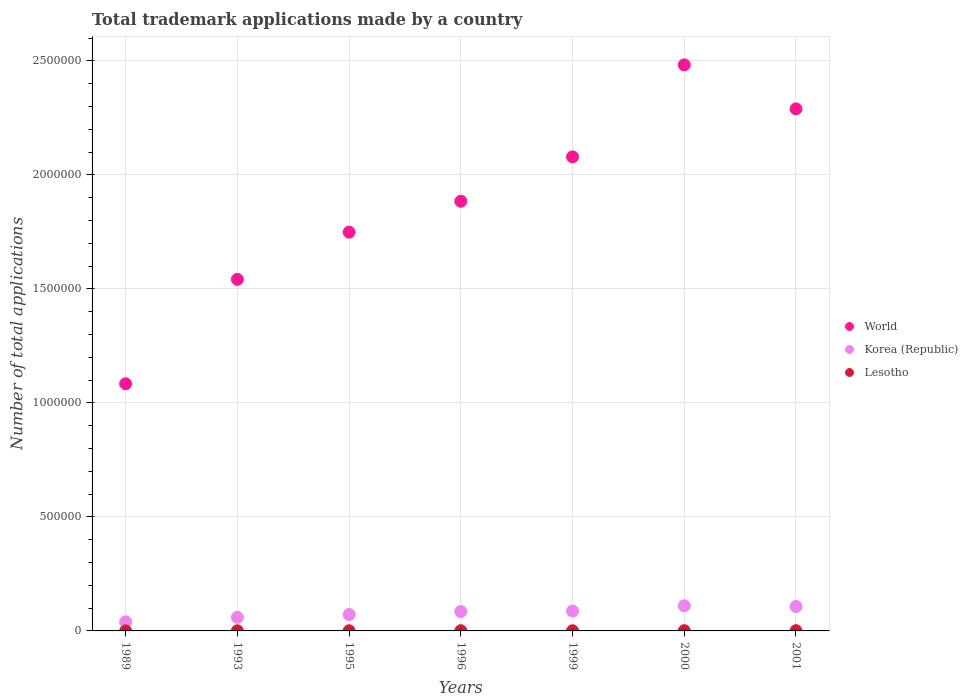How many different coloured dotlines are there?
Provide a short and direct response. 3. Is the number of dotlines equal to the number of legend labels?
Offer a very short reply. Yes. What is the number of applications made by in Korea (Republic) in 1995?
Make the answer very short. 7.19e+04. Across all years, what is the maximum number of applications made by in Lesotho?
Keep it short and to the point. 1083. Across all years, what is the minimum number of applications made by in Lesotho?
Give a very brief answer. 98. In which year was the number of applications made by in Korea (Republic) maximum?
Your answer should be very brief. 2000. In which year was the number of applications made by in Lesotho minimum?
Offer a very short reply. 1989. What is the total number of applications made by in Lesotho in the graph?
Provide a short and direct response. 5022. What is the difference between the number of applications made by in Lesotho in 1993 and that in 1999?
Provide a succinct answer. -84. What is the difference between the number of applications made by in World in 1989 and the number of applications made by in Korea (Republic) in 1999?
Your answer should be very brief. 9.97e+05. What is the average number of applications made by in Lesotho per year?
Give a very brief answer. 717.43. In the year 1996, what is the difference between the number of applications made by in World and number of applications made by in Korea (Republic)?
Keep it short and to the point. 1.80e+06. In how many years, is the number of applications made by in Lesotho greater than 1600000?
Keep it short and to the point. 0. What is the ratio of the number of applications made by in Korea (Republic) in 1996 to that in 1999?
Your answer should be compact. 0.97. What is the difference between the highest and the second highest number of applications made by in World?
Offer a terse response. 1.93e+05. What is the difference between the highest and the lowest number of applications made by in Lesotho?
Keep it short and to the point. 985. Is it the case that in every year, the sum of the number of applications made by in World and number of applications made by in Lesotho  is greater than the number of applications made by in Korea (Republic)?
Your answer should be compact. Yes. Does the number of applications made by in Lesotho monotonically increase over the years?
Offer a very short reply. No. Is the number of applications made by in World strictly greater than the number of applications made by in Lesotho over the years?
Offer a very short reply. Yes. How many dotlines are there?
Offer a very short reply. 3. Does the graph contain grids?
Provide a succinct answer. Yes. Where does the legend appear in the graph?
Your response must be concise. Center right. How are the legend labels stacked?
Ensure brevity in your answer.  Vertical. What is the title of the graph?
Offer a very short reply. Total trademark applications made by a country. What is the label or title of the X-axis?
Give a very brief answer. Years. What is the label or title of the Y-axis?
Give a very brief answer. Number of total applications. What is the Number of total applications of World in 1989?
Provide a short and direct response. 1.08e+06. What is the Number of total applications of Korea (Republic) in 1989?
Keep it short and to the point. 3.98e+04. What is the Number of total applications of Lesotho in 1989?
Ensure brevity in your answer.  98. What is the Number of total applications in World in 1993?
Make the answer very short. 1.54e+06. What is the Number of total applications in Korea (Republic) in 1993?
Provide a succinct answer. 5.96e+04. What is the Number of total applications of Lesotho in 1993?
Offer a terse response. 581. What is the Number of total applications of World in 1995?
Your answer should be very brief. 1.75e+06. What is the Number of total applications of Korea (Republic) in 1995?
Give a very brief answer. 7.19e+04. What is the Number of total applications of Lesotho in 1995?
Your answer should be compact. 668. What is the Number of total applications in World in 1996?
Provide a short and direct response. 1.88e+06. What is the Number of total applications in Korea (Republic) in 1996?
Provide a short and direct response. 8.51e+04. What is the Number of total applications in Lesotho in 1996?
Offer a terse response. 918. What is the Number of total applications of World in 1999?
Ensure brevity in your answer.  2.08e+06. What is the Number of total applications in Korea (Republic) in 1999?
Ensure brevity in your answer.  8.73e+04. What is the Number of total applications in Lesotho in 1999?
Provide a short and direct response. 665. What is the Number of total applications in World in 2000?
Your response must be concise. 2.48e+06. What is the Number of total applications in Korea (Republic) in 2000?
Provide a succinct answer. 1.10e+05. What is the Number of total applications in Lesotho in 2000?
Your answer should be compact. 1083. What is the Number of total applications of World in 2001?
Your response must be concise. 2.29e+06. What is the Number of total applications in Korea (Republic) in 2001?
Keep it short and to the point. 1.07e+05. What is the Number of total applications of Lesotho in 2001?
Your response must be concise. 1009. Across all years, what is the maximum Number of total applications of World?
Your answer should be compact. 2.48e+06. Across all years, what is the maximum Number of total applications in Korea (Republic)?
Your answer should be very brief. 1.10e+05. Across all years, what is the maximum Number of total applications in Lesotho?
Give a very brief answer. 1083. Across all years, what is the minimum Number of total applications of World?
Your response must be concise. 1.08e+06. Across all years, what is the minimum Number of total applications in Korea (Republic)?
Provide a short and direct response. 3.98e+04. What is the total Number of total applications of World in the graph?
Provide a succinct answer. 1.31e+07. What is the total Number of total applications in Korea (Republic) in the graph?
Your response must be concise. 5.61e+05. What is the total Number of total applications in Lesotho in the graph?
Ensure brevity in your answer.  5022. What is the difference between the Number of total applications in World in 1989 and that in 1993?
Ensure brevity in your answer.  -4.58e+05. What is the difference between the Number of total applications of Korea (Republic) in 1989 and that in 1993?
Keep it short and to the point. -1.98e+04. What is the difference between the Number of total applications of Lesotho in 1989 and that in 1993?
Make the answer very short. -483. What is the difference between the Number of total applications in World in 1989 and that in 1995?
Give a very brief answer. -6.65e+05. What is the difference between the Number of total applications in Korea (Republic) in 1989 and that in 1995?
Make the answer very short. -3.20e+04. What is the difference between the Number of total applications of Lesotho in 1989 and that in 1995?
Ensure brevity in your answer.  -570. What is the difference between the Number of total applications in World in 1989 and that in 1996?
Your answer should be very brief. -8.00e+05. What is the difference between the Number of total applications of Korea (Republic) in 1989 and that in 1996?
Provide a short and direct response. -4.52e+04. What is the difference between the Number of total applications in Lesotho in 1989 and that in 1996?
Provide a succinct answer. -820. What is the difference between the Number of total applications in World in 1989 and that in 1999?
Provide a succinct answer. -9.95e+05. What is the difference between the Number of total applications of Korea (Republic) in 1989 and that in 1999?
Keep it short and to the point. -4.75e+04. What is the difference between the Number of total applications of Lesotho in 1989 and that in 1999?
Your response must be concise. -567. What is the difference between the Number of total applications in World in 1989 and that in 2000?
Offer a terse response. -1.40e+06. What is the difference between the Number of total applications of Korea (Republic) in 1989 and that in 2000?
Give a very brief answer. -7.02e+04. What is the difference between the Number of total applications of Lesotho in 1989 and that in 2000?
Your answer should be very brief. -985. What is the difference between the Number of total applications of World in 1989 and that in 2001?
Your answer should be compact. -1.21e+06. What is the difference between the Number of total applications of Korea (Republic) in 1989 and that in 2001?
Make the answer very short. -6.73e+04. What is the difference between the Number of total applications in Lesotho in 1989 and that in 2001?
Provide a short and direct response. -911. What is the difference between the Number of total applications of World in 1993 and that in 1995?
Your response must be concise. -2.07e+05. What is the difference between the Number of total applications in Korea (Republic) in 1993 and that in 1995?
Offer a terse response. -1.23e+04. What is the difference between the Number of total applications of Lesotho in 1993 and that in 1995?
Provide a short and direct response. -87. What is the difference between the Number of total applications of World in 1993 and that in 1996?
Offer a terse response. -3.42e+05. What is the difference between the Number of total applications of Korea (Republic) in 1993 and that in 1996?
Your response must be concise. -2.55e+04. What is the difference between the Number of total applications of Lesotho in 1993 and that in 1996?
Your answer should be very brief. -337. What is the difference between the Number of total applications of World in 1993 and that in 1999?
Offer a very short reply. -5.37e+05. What is the difference between the Number of total applications in Korea (Republic) in 1993 and that in 1999?
Ensure brevity in your answer.  -2.77e+04. What is the difference between the Number of total applications in Lesotho in 1993 and that in 1999?
Give a very brief answer. -84. What is the difference between the Number of total applications of World in 1993 and that in 2000?
Make the answer very short. -9.41e+05. What is the difference between the Number of total applications of Korea (Republic) in 1993 and that in 2000?
Your answer should be compact. -5.05e+04. What is the difference between the Number of total applications of Lesotho in 1993 and that in 2000?
Offer a very short reply. -502. What is the difference between the Number of total applications of World in 1993 and that in 2001?
Keep it short and to the point. -7.48e+05. What is the difference between the Number of total applications of Korea (Republic) in 1993 and that in 2001?
Ensure brevity in your answer.  -4.75e+04. What is the difference between the Number of total applications of Lesotho in 1993 and that in 2001?
Give a very brief answer. -428. What is the difference between the Number of total applications in World in 1995 and that in 1996?
Offer a terse response. -1.35e+05. What is the difference between the Number of total applications of Korea (Republic) in 1995 and that in 1996?
Your answer should be compact. -1.32e+04. What is the difference between the Number of total applications in Lesotho in 1995 and that in 1996?
Make the answer very short. -250. What is the difference between the Number of total applications of World in 1995 and that in 1999?
Offer a very short reply. -3.30e+05. What is the difference between the Number of total applications of Korea (Republic) in 1995 and that in 1999?
Your answer should be compact. -1.55e+04. What is the difference between the Number of total applications in Lesotho in 1995 and that in 1999?
Make the answer very short. 3. What is the difference between the Number of total applications in World in 1995 and that in 2000?
Provide a succinct answer. -7.34e+05. What is the difference between the Number of total applications of Korea (Republic) in 1995 and that in 2000?
Give a very brief answer. -3.82e+04. What is the difference between the Number of total applications in Lesotho in 1995 and that in 2000?
Keep it short and to the point. -415. What is the difference between the Number of total applications in World in 1995 and that in 2001?
Offer a very short reply. -5.41e+05. What is the difference between the Number of total applications in Korea (Republic) in 1995 and that in 2001?
Ensure brevity in your answer.  -3.53e+04. What is the difference between the Number of total applications of Lesotho in 1995 and that in 2001?
Your answer should be very brief. -341. What is the difference between the Number of total applications in World in 1996 and that in 1999?
Your answer should be compact. -1.95e+05. What is the difference between the Number of total applications of Korea (Republic) in 1996 and that in 1999?
Your answer should be very brief. -2270. What is the difference between the Number of total applications of Lesotho in 1996 and that in 1999?
Your response must be concise. 253. What is the difference between the Number of total applications of World in 1996 and that in 2000?
Provide a short and direct response. -5.98e+05. What is the difference between the Number of total applications of Korea (Republic) in 1996 and that in 2000?
Offer a very short reply. -2.50e+04. What is the difference between the Number of total applications in Lesotho in 1996 and that in 2000?
Keep it short and to the point. -165. What is the difference between the Number of total applications of World in 1996 and that in 2001?
Give a very brief answer. -4.05e+05. What is the difference between the Number of total applications in Korea (Republic) in 1996 and that in 2001?
Your answer should be compact. -2.21e+04. What is the difference between the Number of total applications of Lesotho in 1996 and that in 2001?
Your answer should be very brief. -91. What is the difference between the Number of total applications in World in 1999 and that in 2000?
Ensure brevity in your answer.  -4.03e+05. What is the difference between the Number of total applications in Korea (Republic) in 1999 and that in 2000?
Keep it short and to the point. -2.27e+04. What is the difference between the Number of total applications of Lesotho in 1999 and that in 2000?
Your answer should be compact. -418. What is the difference between the Number of total applications of World in 1999 and that in 2001?
Offer a terse response. -2.11e+05. What is the difference between the Number of total applications in Korea (Republic) in 1999 and that in 2001?
Give a very brief answer. -1.98e+04. What is the difference between the Number of total applications of Lesotho in 1999 and that in 2001?
Offer a terse response. -344. What is the difference between the Number of total applications of World in 2000 and that in 2001?
Your answer should be compact. 1.93e+05. What is the difference between the Number of total applications in Korea (Republic) in 2000 and that in 2001?
Make the answer very short. 2936. What is the difference between the Number of total applications of World in 1989 and the Number of total applications of Korea (Republic) in 1993?
Your answer should be very brief. 1.02e+06. What is the difference between the Number of total applications in World in 1989 and the Number of total applications in Lesotho in 1993?
Provide a short and direct response. 1.08e+06. What is the difference between the Number of total applications of Korea (Republic) in 1989 and the Number of total applications of Lesotho in 1993?
Offer a terse response. 3.93e+04. What is the difference between the Number of total applications in World in 1989 and the Number of total applications in Korea (Republic) in 1995?
Your answer should be compact. 1.01e+06. What is the difference between the Number of total applications of World in 1989 and the Number of total applications of Lesotho in 1995?
Your answer should be very brief. 1.08e+06. What is the difference between the Number of total applications in Korea (Republic) in 1989 and the Number of total applications in Lesotho in 1995?
Offer a terse response. 3.92e+04. What is the difference between the Number of total applications of World in 1989 and the Number of total applications of Korea (Republic) in 1996?
Your response must be concise. 9.99e+05. What is the difference between the Number of total applications of World in 1989 and the Number of total applications of Lesotho in 1996?
Your answer should be very brief. 1.08e+06. What is the difference between the Number of total applications in Korea (Republic) in 1989 and the Number of total applications in Lesotho in 1996?
Keep it short and to the point. 3.89e+04. What is the difference between the Number of total applications in World in 1989 and the Number of total applications in Korea (Republic) in 1999?
Offer a very short reply. 9.97e+05. What is the difference between the Number of total applications in World in 1989 and the Number of total applications in Lesotho in 1999?
Make the answer very short. 1.08e+06. What is the difference between the Number of total applications in Korea (Republic) in 1989 and the Number of total applications in Lesotho in 1999?
Provide a succinct answer. 3.92e+04. What is the difference between the Number of total applications of World in 1989 and the Number of total applications of Korea (Republic) in 2000?
Give a very brief answer. 9.74e+05. What is the difference between the Number of total applications in World in 1989 and the Number of total applications in Lesotho in 2000?
Keep it short and to the point. 1.08e+06. What is the difference between the Number of total applications of Korea (Republic) in 1989 and the Number of total applications of Lesotho in 2000?
Offer a very short reply. 3.87e+04. What is the difference between the Number of total applications in World in 1989 and the Number of total applications in Korea (Republic) in 2001?
Offer a very short reply. 9.77e+05. What is the difference between the Number of total applications in World in 1989 and the Number of total applications in Lesotho in 2001?
Ensure brevity in your answer.  1.08e+06. What is the difference between the Number of total applications in Korea (Republic) in 1989 and the Number of total applications in Lesotho in 2001?
Your answer should be compact. 3.88e+04. What is the difference between the Number of total applications in World in 1993 and the Number of total applications in Korea (Republic) in 1995?
Your response must be concise. 1.47e+06. What is the difference between the Number of total applications of World in 1993 and the Number of total applications of Lesotho in 1995?
Offer a very short reply. 1.54e+06. What is the difference between the Number of total applications in Korea (Republic) in 1993 and the Number of total applications in Lesotho in 1995?
Make the answer very short. 5.89e+04. What is the difference between the Number of total applications of World in 1993 and the Number of total applications of Korea (Republic) in 1996?
Your answer should be compact. 1.46e+06. What is the difference between the Number of total applications in World in 1993 and the Number of total applications in Lesotho in 1996?
Give a very brief answer. 1.54e+06. What is the difference between the Number of total applications of Korea (Republic) in 1993 and the Number of total applications of Lesotho in 1996?
Provide a succinct answer. 5.87e+04. What is the difference between the Number of total applications in World in 1993 and the Number of total applications in Korea (Republic) in 1999?
Your answer should be compact. 1.45e+06. What is the difference between the Number of total applications of World in 1993 and the Number of total applications of Lesotho in 1999?
Provide a succinct answer. 1.54e+06. What is the difference between the Number of total applications in Korea (Republic) in 1993 and the Number of total applications in Lesotho in 1999?
Offer a very short reply. 5.89e+04. What is the difference between the Number of total applications of World in 1993 and the Number of total applications of Korea (Republic) in 2000?
Offer a terse response. 1.43e+06. What is the difference between the Number of total applications in World in 1993 and the Number of total applications in Lesotho in 2000?
Offer a terse response. 1.54e+06. What is the difference between the Number of total applications in Korea (Republic) in 1993 and the Number of total applications in Lesotho in 2000?
Keep it short and to the point. 5.85e+04. What is the difference between the Number of total applications of World in 1993 and the Number of total applications of Korea (Republic) in 2001?
Provide a succinct answer. 1.43e+06. What is the difference between the Number of total applications of World in 1993 and the Number of total applications of Lesotho in 2001?
Give a very brief answer. 1.54e+06. What is the difference between the Number of total applications in Korea (Republic) in 1993 and the Number of total applications in Lesotho in 2001?
Your answer should be compact. 5.86e+04. What is the difference between the Number of total applications of World in 1995 and the Number of total applications of Korea (Republic) in 1996?
Ensure brevity in your answer.  1.66e+06. What is the difference between the Number of total applications of World in 1995 and the Number of total applications of Lesotho in 1996?
Your answer should be compact. 1.75e+06. What is the difference between the Number of total applications in Korea (Republic) in 1995 and the Number of total applications in Lesotho in 1996?
Offer a terse response. 7.09e+04. What is the difference between the Number of total applications of World in 1995 and the Number of total applications of Korea (Republic) in 1999?
Keep it short and to the point. 1.66e+06. What is the difference between the Number of total applications of World in 1995 and the Number of total applications of Lesotho in 1999?
Your answer should be very brief. 1.75e+06. What is the difference between the Number of total applications of Korea (Republic) in 1995 and the Number of total applications of Lesotho in 1999?
Your answer should be very brief. 7.12e+04. What is the difference between the Number of total applications in World in 1995 and the Number of total applications in Korea (Republic) in 2000?
Provide a short and direct response. 1.64e+06. What is the difference between the Number of total applications of World in 1995 and the Number of total applications of Lesotho in 2000?
Ensure brevity in your answer.  1.75e+06. What is the difference between the Number of total applications of Korea (Republic) in 1995 and the Number of total applications of Lesotho in 2000?
Make the answer very short. 7.08e+04. What is the difference between the Number of total applications in World in 1995 and the Number of total applications in Korea (Republic) in 2001?
Your answer should be very brief. 1.64e+06. What is the difference between the Number of total applications of World in 1995 and the Number of total applications of Lesotho in 2001?
Offer a terse response. 1.75e+06. What is the difference between the Number of total applications in Korea (Republic) in 1995 and the Number of total applications in Lesotho in 2001?
Your answer should be very brief. 7.08e+04. What is the difference between the Number of total applications of World in 1996 and the Number of total applications of Korea (Republic) in 1999?
Your response must be concise. 1.80e+06. What is the difference between the Number of total applications in World in 1996 and the Number of total applications in Lesotho in 1999?
Ensure brevity in your answer.  1.88e+06. What is the difference between the Number of total applications of Korea (Republic) in 1996 and the Number of total applications of Lesotho in 1999?
Your response must be concise. 8.44e+04. What is the difference between the Number of total applications in World in 1996 and the Number of total applications in Korea (Republic) in 2000?
Make the answer very short. 1.77e+06. What is the difference between the Number of total applications of World in 1996 and the Number of total applications of Lesotho in 2000?
Ensure brevity in your answer.  1.88e+06. What is the difference between the Number of total applications of Korea (Republic) in 1996 and the Number of total applications of Lesotho in 2000?
Your answer should be very brief. 8.40e+04. What is the difference between the Number of total applications of World in 1996 and the Number of total applications of Korea (Republic) in 2001?
Your answer should be very brief. 1.78e+06. What is the difference between the Number of total applications of World in 1996 and the Number of total applications of Lesotho in 2001?
Give a very brief answer. 1.88e+06. What is the difference between the Number of total applications of Korea (Republic) in 1996 and the Number of total applications of Lesotho in 2001?
Offer a very short reply. 8.41e+04. What is the difference between the Number of total applications of World in 1999 and the Number of total applications of Korea (Republic) in 2000?
Your answer should be very brief. 1.97e+06. What is the difference between the Number of total applications of World in 1999 and the Number of total applications of Lesotho in 2000?
Offer a very short reply. 2.08e+06. What is the difference between the Number of total applications in Korea (Republic) in 1999 and the Number of total applications in Lesotho in 2000?
Offer a terse response. 8.62e+04. What is the difference between the Number of total applications in World in 1999 and the Number of total applications in Korea (Republic) in 2001?
Offer a terse response. 1.97e+06. What is the difference between the Number of total applications in World in 1999 and the Number of total applications in Lesotho in 2001?
Your answer should be compact. 2.08e+06. What is the difference between the Number of total applications in Korea (Republic) in 1999 and the Number of total applications in Lesotho in 2001?
Offer a terse response. 8.63e+04. What is the difference between the Number of total applications of World in 2000 and the Number of total applications of Korea (Republic) in 2001?
Your response must be concise. 2.38e+06. What is the difference between the Number of total applications of World in 2000 and the Number of total applications of Lesotho in 2001?
Provide a short and direct response. 2.48e+06. What is the difference between the Number of total applications in Korea (Republic) in 2000 and the Number of total applications in Lesotho in 2001?
Keep it short and to the point. 1.09e+05. What is the average Number of total applications of World per year?
Offer a terse response. 1.87e+06. What is the average Number of total applications of Korea (Republic) per year?
Your response must be concise. 8.01e+04. What is the average Number of total applications of Lesotho per year?
Offer a terse response. 717.43. In the year 1989, what is the difference between the Number of total applications in World and Number of total applications in Korea (Republic)?
Your answer should be very brief. 1.04e+06. In the year 1989, what is the difference between the Number of total applications of World and Number of total applications of Lesotho?
Your response must be concise. 1.08e+06. In the year 1989, what is the difference between the Number of total applications of Korea (Republic) and Number of total applications of Lesotho?
Give a very brief answer. 3.97e+04. In the year 1993, what is the difference between the Number of total applications of World and Number of total applications of Korea (Republic)?
Ensure brevity in your answer.  1.48e+06. In the year 1993, what is the difference between the Number of total applications in World and Number of total applications in Lesotho?
Ensure brevity in your answer.  1.54e+06. In the year 1993, what is the difference between the Number of total applications of Korea (Republic) and Number of total applications of Lesotho?
Your response must be concise. 5.90e+04. In the year 1995, what is the difference between the Number of total applications in World and Number of total applications in Korea (Republic)?
Provide a succinct answer. 1.68e+06. In the year 1995, what is the difference between the Number of total applications of World and Number of total applications of Lesotho?
Provide a succinct answer. 1.75e+06. In the year 1995, what is the difference between the Number of total applications of Korea (Republic) and Number of total applications of Lesotho?
Provide a succinct answer. 7.12e+04. In the year 1996, what is the difference between the Number of total applications in World and Number of total applications in Korea (Republic)?
Give a very brief answer. 1.80e+06. In the year 1996, what is the difference between the Number of total applications of World and Number of total applications of Lesotho?
Your response must be concise. 1.88e+06. In the year 1996, what is the difference between the Number of total applications in Korea (Republic) and Number of total applications in Lesotho?
Make the answer very short. 8.41e+04. In the year 1999, what is the difference between the Number of total applications of World and Number of total applications of Korea (Republic)?
Your response must be concise. 1.99e+06. In the year 1999, what is the difference between the Number of total applications of World and Number of total applications of Lesotho?
Offer a very short reply. 2.08e+06. In the year 1999, what is the difference between the Number of total applications in Korea (Republic) and Number of total applications in Lesotho?
Your answer should be very brief. 8.67e+04. In the year 2000, what is the difference between the Number of total applications of World and Number of total applications of Korea (Republic)?
Keep it short and to the point. 2.37e+06. In the year 2000, what is the difference between the Number of total applications in World and Number of total applications in Lesotho?
Offer a terse response. 2.48e+06. In the year 2000, what is the difference between the Number of total applications in Korea (Republic) and Number of total applications in Lesotho?
Give a very brief answer. 1.09e+05. In the year 2001, what is the difference between the Number of total applications in World and Number of total applications in Korea (Republic)?
Your answer should be compact. 2.18e+06. In the year 2001, what is the difference between the Number of total applications of World and Number of total applications of Lesotho?
Provide a succinct answer. 2.29e+06. In the year 2001, what is the difference between the Number of total applications in Korea (Republic) and Number of total applications in Lesotho?
Make the answer very short. 1.06e+05. What is the ratio of the Number of total applications in World in 1989 to that in 1993?
Give a very brief answer. 0.7. What is the ratio of the Number of total applications of Korea (Republic) in 1989 to that in 1993?
Keep it short and to the point. 0.67. What is the ratio of the Number of total applications of Lesotho in 1989 to that in 1993?
Your response must be concise. 0.17. What is the ratio of the Number of total applications of World in 1989 to that in 1995?
Your answer should be compact. 0.62. What is the ratio of the Number of total applications of Korea (Republic) in 1989 to that in 1995?
Give a very brief answer. 0.55. What is the ratio of the Number of total applications of Lesotho in 1989 to that in 1995?
Your answer should be compact. 0.15. What is the ratio of the Number of total applications in World in 1989 to that in 1996?
Offer a very short reply. 0.58. What is the ratio of the Number of total applications of Korea (Republic) in 1989 to that in 1996?
Make the answer very short. 0.47. What is the ratio of the Number of total applications in Lesotho in 1989 to that in 1996?
Provide a succinct answer. 0.11. What is the ratio of the Number of total applications in World in 1989 to that in 1999?
Your answer should be very brief. 0.52. What is the ratio of the Number of total applications of Korea (Republic) in 1989 to that in 1999?
Ensure brevity in your answer.  0.46. What is the ratio of the Number of total applications in Lesotho in 1989 to that in 1999?
Ensure brevity in your answer.  0.15. What is the ratio of the Number of total applications in World in 1989 to that in 2000?
Your response must be concise. 0.44. What is the ratio of the Number of total applications in Korea (Republic) in 1989 to that in 2000?
Offer a very short reply. 0.36. What is the ratio of the Number of total applications of Lesotho in 1989 to that in 2000?
Provide a succinct answer. 0.09. What is the ratio of the Number of total applications in World in 1989 to that in 2001?
Ensure brevity in your answer.  0.47. What is the ratio of the Number of total applications of Korea (Republic) in 1989 to that in 2001?
Your response must be concise. 0.37. What is the ratio of the Number of total applications in Lesotho in 1989 to that in 2001?
Provide a short and direct response. 0.1. What is the ratio of the Number of total applications in World in 1993 to that in 1995?
Provide a short and direct response. 0.88. What is the ratio of the Number of total applications of Korea (Republic) in 1993 to that in 1995?
Provide a succinct answer. 0.83. What is the ratio of the Number of total applications in Lesotho in 1993 to that in 1995?
Ensure brevity in your answer.  0.87. What is the ratio of the Number of total applications in World in 1993 to that in 1996?
Provide a succinct answer. 0.82. What is the ratio of the Number of total applications in Korea (Republic) in 1993 to that in 1996?
Give a very brief answer. 0.7. What is the ratio of the Number of total applications in Lesotho in 1993 to that in 1996?
Make the answer very short. 0.63. What is the ratio of the Number of total applications of World in 1993 to that in 1999?
Your answer should be very brief. 0.74. What is the ratio of the Number of total applications of Korea (Republic) in 1993 to that in 1999?
Provide a succinct answer. 0.68. What is the ratio of the Number of total applications in Lesotho in 1993 to that in 1999?
Keep it short and to the point. 0.87. What is the ratio of the Number of total applications in World in 1993 to that in 2000?
Keep it short and to the point. 0.62. What is the ratio of the Number of total applications of Korea (Republic) in 1993 to that in 2000?
Keep it short and to the point. 0.54. What is the ratio of the Number of total applications of Lesotho in 1993 to that in 2000?
Give a very brief answer. 0.54. What is the ratio of the Number of total applications of World in 1993 to that in 2001?
Your response must be concise. 0.67. What is the ratio of the Number of total applications in Korea (Republic) in 1993 to that in 2001?
Keep it short and to the point. 0.56. What is the ratio of the Number of total applications in Lesotho in 1993 to that in 2001?
Your answer should be compact. 0.58. What is the ratio of the Number of total applications of World in 1995 to that in 1996?
Provide a short and direct response. 0.93. What is the ratio of the Number of total applications of Korea (Republic) in 1995 to that in 1996?
Keep it short and to the point. 0.84. What is the ratio of the Number of total applications in Lesotho in 1995 to that in 1996?
Keep it short and to the point. 0.73. What is the ratio of the Number of total applications in World in 1995 to that in 1999?
Your answer should be compact. 0.84. What is the ratio of the Number of total applications of Korea (Republic) in 1995 to that in 1999?
Keep it short and to the point. 0.82. What is the ratio of the Number of total applications of World in 1995 to that in 2000?
Provide a short and direct response. 0.7. What is the ratio of the Number of total applications of Korea (Republic) in 1995 to that in 2000?
Provide a short and direct response. 0.65. What is the ratio of the Number of total applications in Lesotho in 1995 to that in 2000?
Your answer should be very brief. 0.62. What is the ratio of the Number of total applications of World in 1995 to that in 2001?
Ensure brevity in your answer.  0.76. What is the ratio of the Number of total applications of Korea (Republic) in 1995 to that in 2001?
Give a very brief answer. 0.67. What is the ratio of the Number of total applications of Lesotho in 1995 to that in 2001?
Make the answer very short. 0.66. What is the ratio of the Number of total applications in World in 1996 to that in 1999?
Your response must be concise. 0.91. What is the ratio of the Number of total applications of Korea (Republic) in 1996 to that in 1999?
Offer a terse response. 0.97. What is the ratio of the Number of total applications in Lesotho in 1996 to that in 1999?
Ensure brevity in your answer.  1.38. What is the ratio of the Number of total applications in World in 1996 to that in 2000?
Offer a very short reply. 0.76. What is the ratio of the Number of total applications of Korea (Republic) in 1996 to that in 2000?
Your response must be concise. 0.77. What is the ratio of the Number of total applications in Lesotho in 1996 to that in 2000?
Keep it short and to the point. 0.85. What is the ratio of the Number of total applications in World in 1996 to that in 2001?
Offer a terse response. 0.82. What is the ratio of the Number of total applications of Korea (Republic) in 1996 to that in 2001?
Make the answer very short. 0.79. What is the ratio of the Number of total applications in Lesotho in 1996 to that in 2001?
Provide a succinct answer. 0.91. What is the ratio of the Number of total applications in World in 1999 to that in 2000?
Ensure brevity in your answer.  0.84. What is the ratio of the Number of total applications in Korea (Republic) in 1999 to that in 2000?
Your answer should be very brief. 0.79. What is the ratio of the Number of total applications of Lesotho in 1999 to that in 2000?
Your answer should be compact. 0.61. What is the ratio of the Number of total applications in World in 1999 to that in 2001?
Give a very brief answer. 0.91. What is the ratio of the Number of total applications in Korea (Republic) in 1999 to that in 2001?
Offer a terse response. 0.82. What is the ratio of the Number of total applications of Lesotho in 1999 to that in 2001?
Make the answer very short. 0.66. What is the ratio of the Number of total applications in World in 2000 to that in 2001?
Your answer should be compact. 1.08. What is the ratio of the Number of total applications in Korea (Republic) in 2000 to that in 2001?
Ensure brevity in your answer.  1.03. What is the ratio of the Number of total applications of Lesotho in 2000 to that in 2001?
Make the answer very short. 1.07. What is the difference between the highest and the second highest Number of total applications in World?
Make the answer very short. 1.93e+05. What is the difference between the highest and the second highest Number of total applications of Korea (Republic)?
Provide a succinct answer. 2936. What is the difference between the highest and the second highest Number of total applications in Lesotho?
Give a very brief answer. 74. What is the difference between the highest and the lowest Number of total applications of World?
Your answer should be very brief. 1.40e+06. What is the difference between the highest and the lowest Number of total applications in Korea (Republic)?
Give a very brief answer. 7.02e+04. What is the difference between the highest and the lowest Number of total applications of Lesotho?
Your response must be concise. 985. 